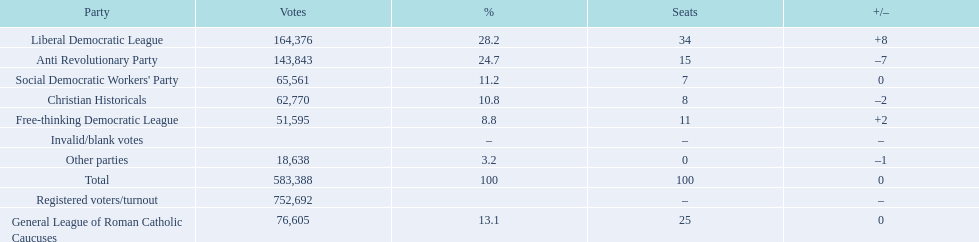How many votes were counted as invalid or blank votes? 0. 